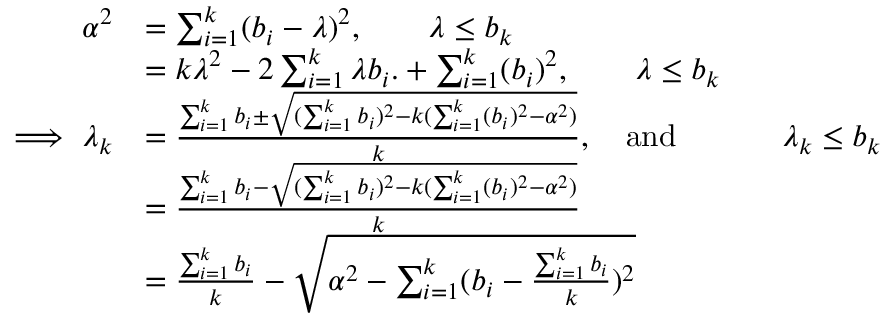<formula> <loc_0><loc_0><loc_500><loc_500>\begin{array} { r l } { \alpha ^ { 2 } } & { = \sum _ { i = 1 } ^ { k } ( b _ { i } - \lambda ) ^ { 2 } , \quad \lambda \leq b _ { k } } \\ & { = k \lambda ^ { 2 } - 2 \sum _ { i = 1 } ^ { k } \lambda b _ { i } . + \sum _ { i = 1 } ^ { k } ( b _ { i } ) ^ { 2 } , \quad \lambda \leq b _ { k } } \\ { \implies \lambda _ { k } } & { = \frac { \sum _ { i = 1 } ^ { k } b _ { i } \pm \sqrt { ( \sum _ { i = 1 } ^ { k } b _ { i } ) ^ { 2 } - k ( \sum _ { i = 1 } ^ { k } ( b _ { i } ) ^ { 2 } - \alpha ^ { 2 } ) } } { k } , \quad a n d \quad \lambda _ { k } \leq b _ { k } } \\ & { = \frac { \sum _ { i = 1 } ^ { k } b _ { i } - \sqrt { ( \sum _ { i = 1 } ^ { k } b _ { i } ) ^ { 2 } - k ( \sum _ { i = 1 } ^ { k } ( b _ { i } ) ^ { 2 } - \alpha ^ { 2 } ) } } { k } } \\ & { = \frac { \sum _ { i = 1 } ^ { k } b _ { i } } { k } - \sqrt { \alpha ^ { 2 } - \sum _ { i = 1 } ^ { k } ( b _ { i } - \frac { \sum _ { i = 1 } ^ { k } b _ { i } } { k } ) ^ { 2 } } } \end{array}</formula> 